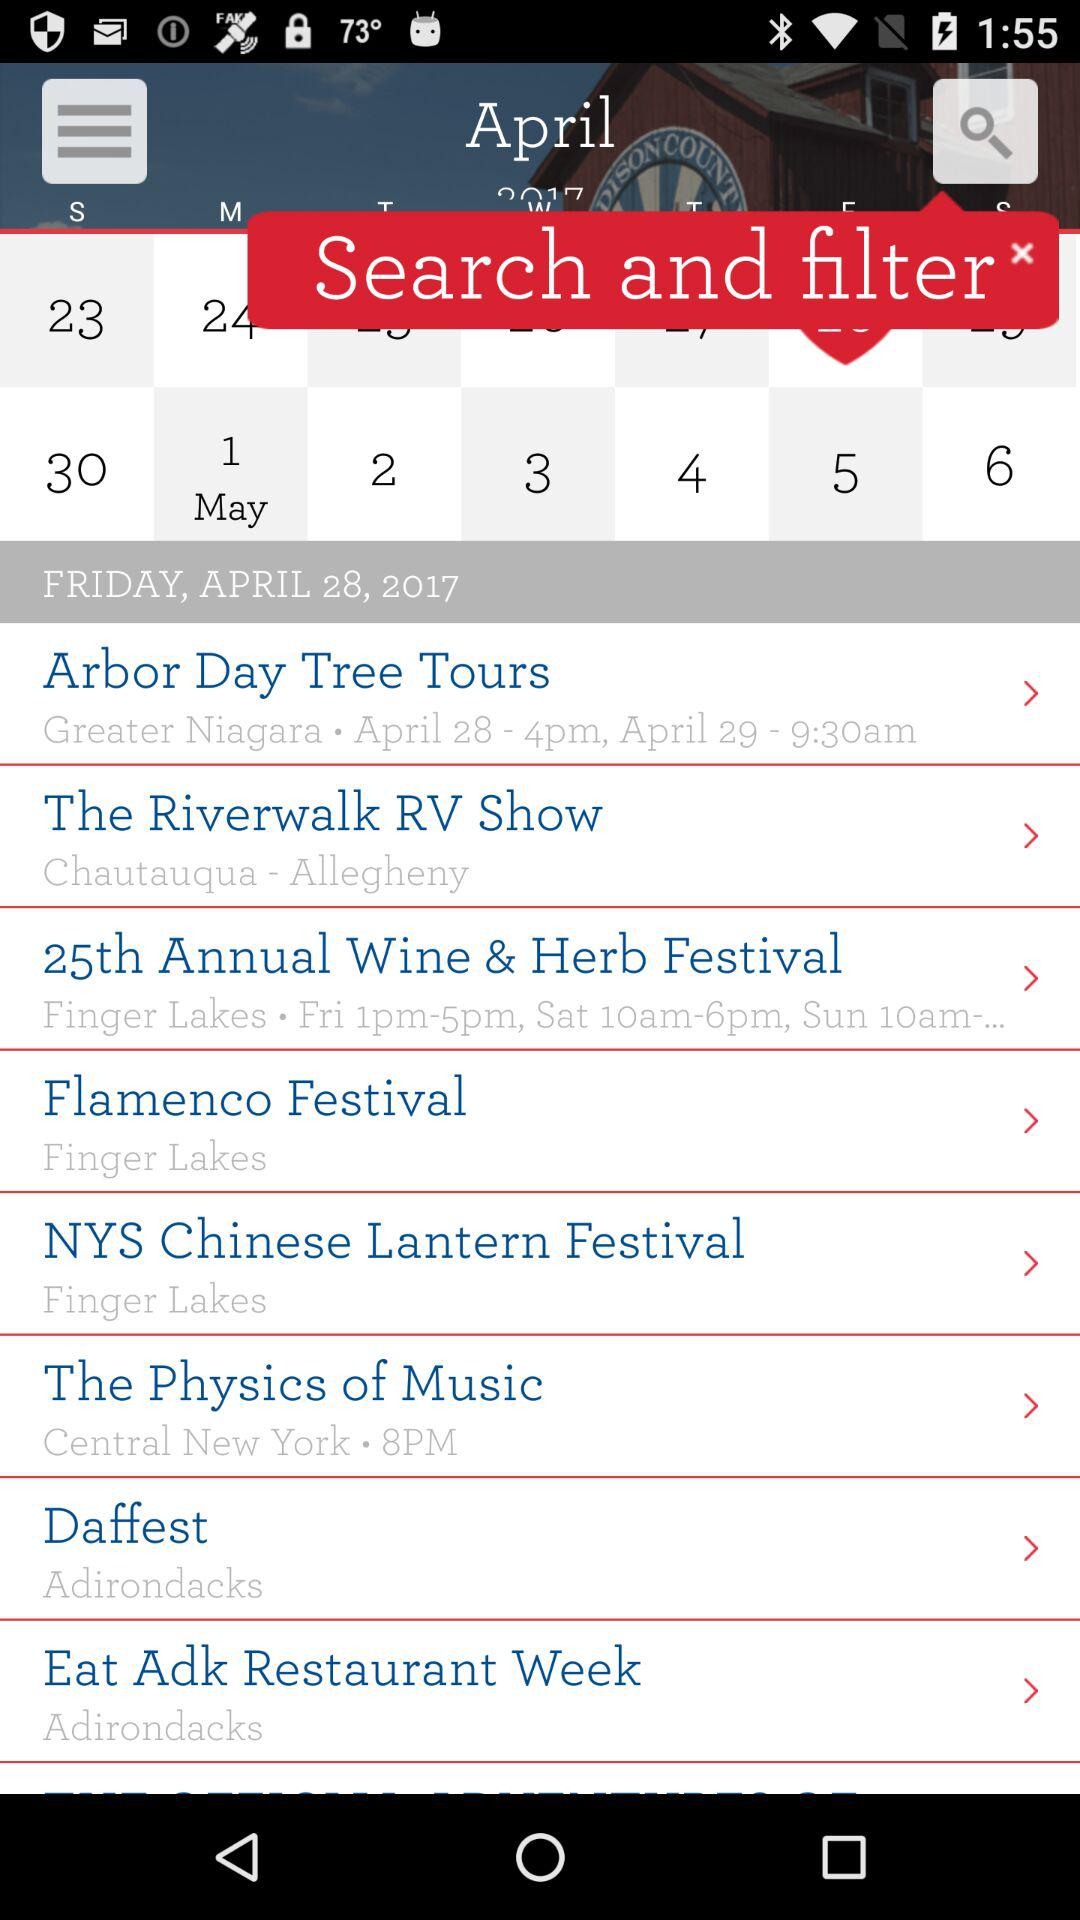What is the date given?
When the provided information is insufficient, respond with <no answer>. <no answer> 